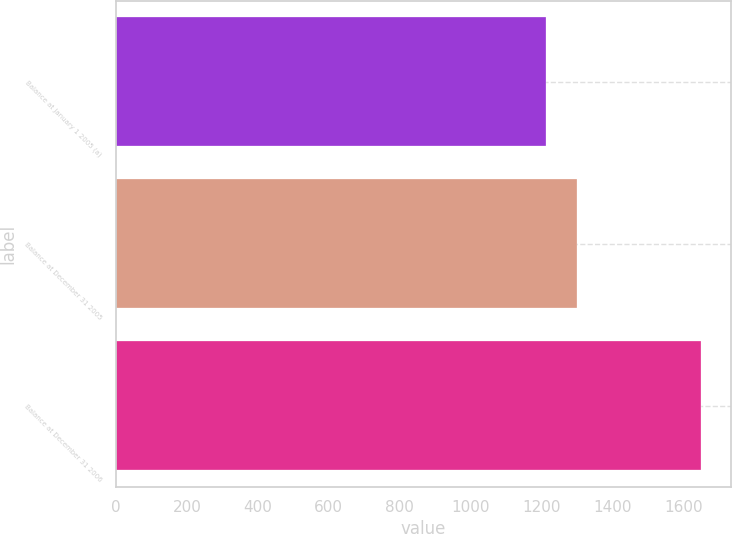Convert chart. <chart><loc_0><loc_0><loc_500><loc_500><bar_chart><fcel>Balance at January 1 2005 (a)<fcel>Balance at December 31 2005<fcel>Balance at December 31 2006<nl><fcel>1214<fcel>1299<fcel>1651<nl></chart> 